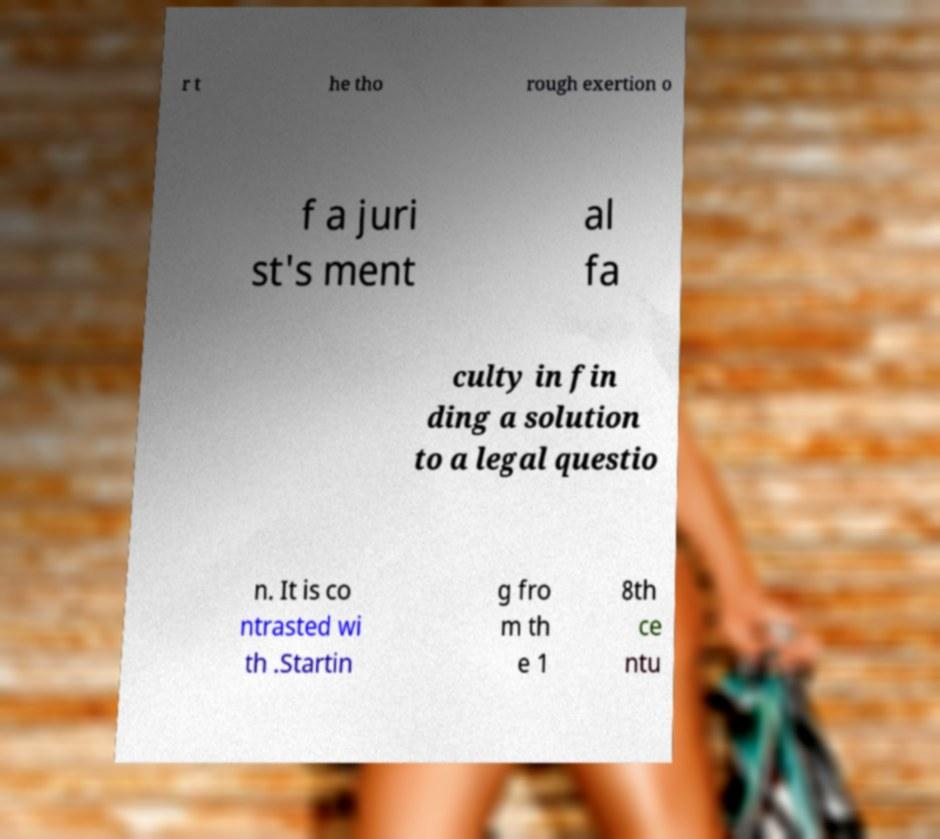Please identify and transcribe the text found in this image. r t he tho rough exertion o f a juri st's ment al fa culty in fin ding a solution to a legal questio n. It is co ntrasted wi th .Startin g fro m th e 1 8th ce ntu 